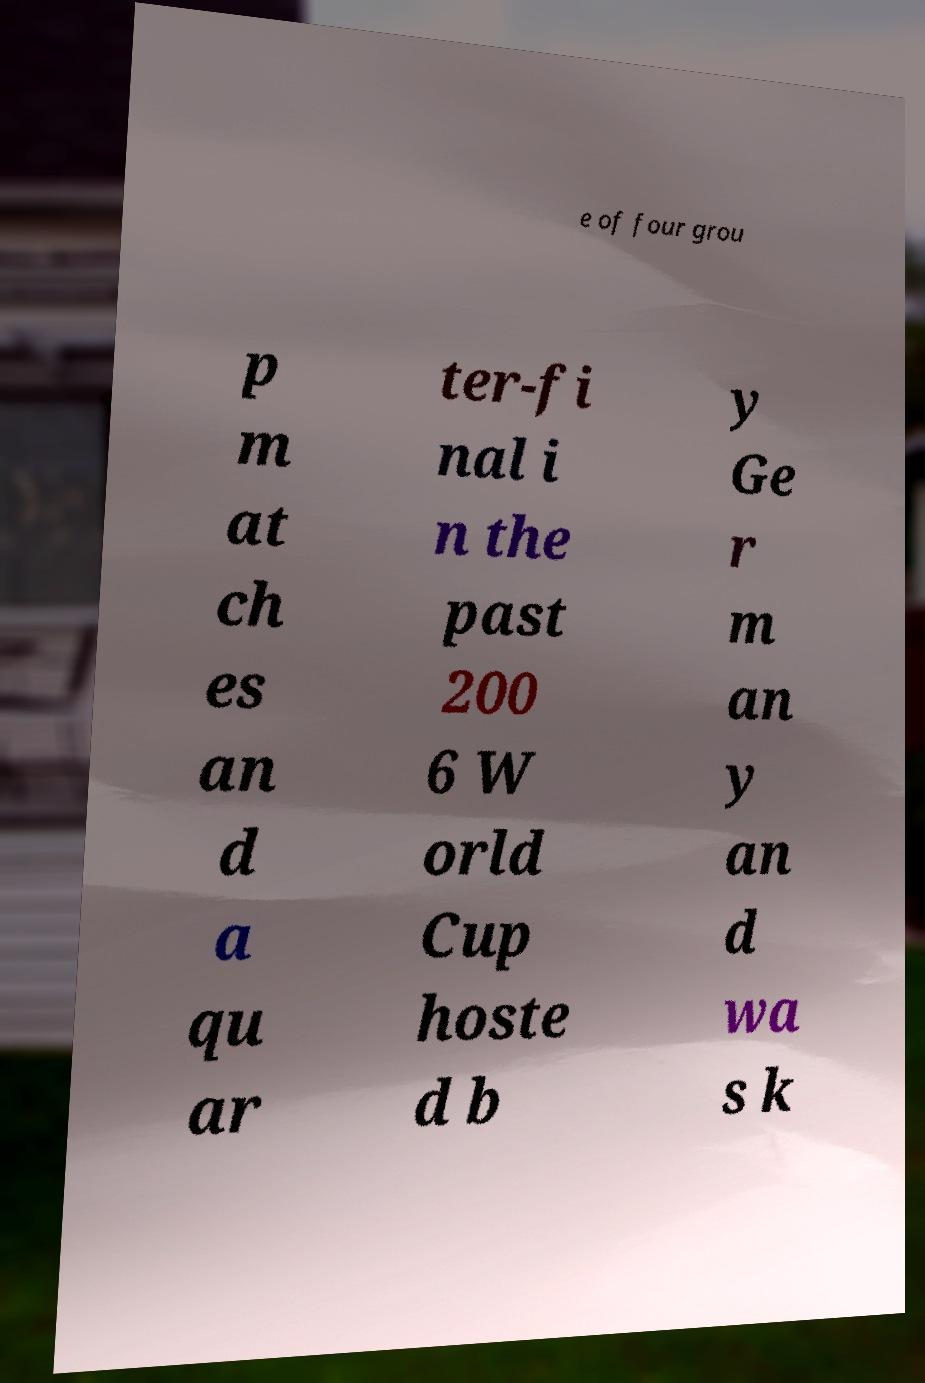I need the written content from this picture converted into text. Can you do that? e of four grou p m at ch es an d a qu ar ter-fi nal i n the past 200 6 W orld Cup hoste d b y Ge r m an y an d wa s k 